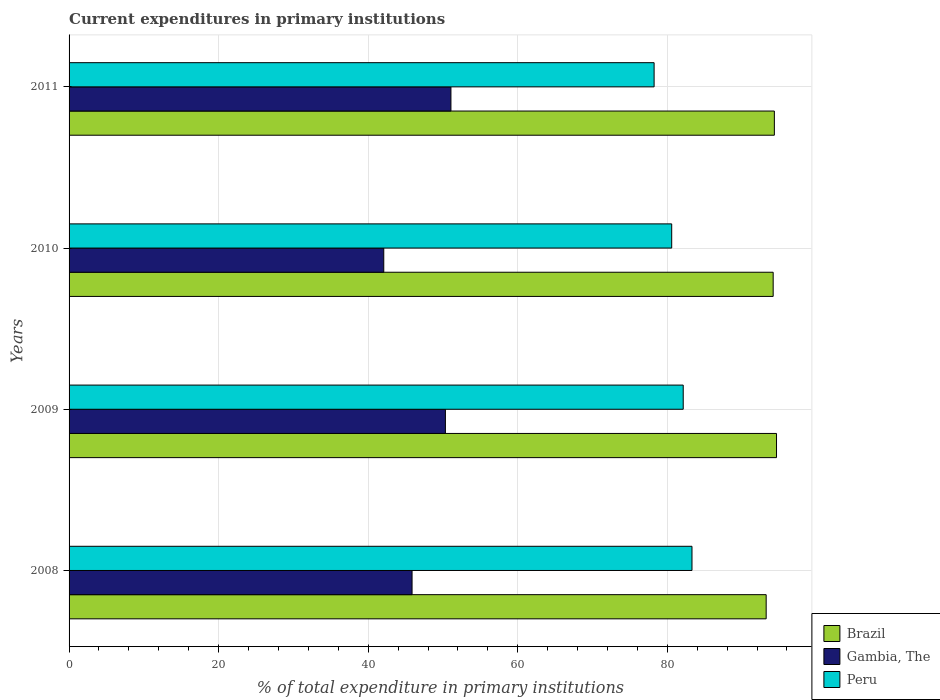How many different coloured bars are there?
Your response must be concise. 3. What is the label of the 1st group of bars from the top?
Make the answer very short. 2011. In how many cases, is the number of bars for a given year not equal to the number of legend labels?
Your response must be concise. 0. What is the current expenditures in primary institutions in Peru in 2008?
Ensure brevity in your answer.  83.3. Across all years, what is the maximum current expenditures in primary institutions in Peru?
Offer a very short reply. 83.3. Across all years, what is the minimum current expenditures in primary institutions in Peru?
Keep it short and to the point. 78.24. In which year was the current expenditures in primary institutions in Gambia, The maximum?
Provide a succinct answer. 2011. In which year was the current expenditures in primary institutions in Brazil minimum?
Keep it short and to the point. 2008. What is the total current expenditures in primary institutions in Brazil in the graph?
Make the answer very short. 376.3. What is the difference between the current expenditures in primary institutions in Brazil in 2008 and that in 2010?
Your answer should be very brief. -0.94. What is the difference between the current expenditures in primary institutions in Gambia, The in 2010 and the current expenditures in primary institutions in Peru in 2009?
Offer a very short reply. -40.05. What is the average current expenditures in primary institutions in Gambia, The per year?
Give a very brief answer. 47.34. In the year 2011, what is the difference between the current expenditures in primary institutions in Peru and current expenditures in primary institutions in Gambia, The?
Your answer should be compact. 27.17. In how many years, is the current expenditures in primary institutions in Peru greater than 40 %?
Your answer should be compact. 4. What is the ratio of the current expenditures in primary institutions in Gambia, The in 2008 to that in 2010?
Offer a very short reply. 1.09. What is the difference between the highest and the second highest current expenditures in primary institutions in Gambia, The?
Give a very brief answer. 0.74. What is the difference between the highest and the lowest current expenditures in primary institutions in Peru?
Offer a terse response. 5.07. Is the sum of the current expenditures in primary institutions in Gambia, The in 2010 and 2011 greater than the maximum current expenditures in primary institutions in Peru across all years?
Your answer should be compact. Yes. What does the 2nd bar from the top in 2008 represents?
Your response must be concise. Gambia, The. How many years are there in the graph?
Make the answer very short. 4. Does the graph contain grids?
Keep it short and to the point. Yes. How are the legend labels stacked?
Provide a succinct answer. Vertical. What is the title of the graph?
Keep it short and to the point. Current expenditures in primary institutions. What is the label or title of the X-axis?
Offer a terse response. % of total expenditure in primary institutions. What is the label or title of the Y-axis?
Offer a very short reply. Years. What is the % of total expenditure in primary institutions of Brazil in 2008?
Your response must be concise. 93.22. What is the % of total expenditure in primary institutions in Gambia, The in 2008?
Make the answer very short. 45.87. What is the % of total expenditure in primary institutions in Peru in 2008?
Give a very brief answer. 83.3. What is the % of total expenditure in primary institutions of Brazil in 2009?
Give a very brief answer. 94.6. What is the % of total expenditure in primary institutions in Gambia, The in 2009?
Offer a very short reply. 50.33. What is the % of total expenditure in primary institutions of Peru in 2009?
Provide a short and direct response. 82.13. What is the % of total expenditure in primary institutions in Brazil in 2010?
Offer a very short reply. 94.16. What is the % of total expenditure in primary institutions of Gambia, The in 2010?
Your answer should be compact. 42.08. What is the % of total expenditure in primary institutions in Peru in 2010?
Offer a very short reply. 80.59. What is the % of total expenditure in primary institutions in Brazil in 2011?
Make the answer very short. 94.32. What is the % of total expenditure in primary institutions in Gambia, The in 2011?
Your answer should be very brief. 51.07. What is the % of total expenditure in primary institutions in Peru in 2011?
Provide a short and direct response. 78.24. Across all years, what is the maximum % of total expenditure in primary institutions of Brazil?
Provide a short and direct response. 94.6. Across all years, what is the maximum % of total expenditure in primary institutions in Gambia, The?
Ensure brevity in your answer.  51.07. Across all years, what is the maximum % of total expenditure in primary institutions in Peru?
Provide a succinct answer. 83.3. Across all years, what is the minimum % of total expenditure in primary institutions of Brazil?
Your answer should be compact. 93.22. Across all years, what is the minimum % of total expenditure in primary institutions in Gambia, The?
Offer a terse response. 42.08. Across all years, what is the minimum % of total expenditure in primary institutions of Peru?
Give a very brief answer. 78.24. What is the total % of total expenditure in primary institutions in Brazil in the graph?
Provide a short and direct response. 376.3. What is the total % of total expenditure in primary institutions of Gambia, The in the graph?
Keep it short and to the point. 189.34. What is the total % of total expenditure in primary institutions of Peru in the graph?
Keep it short and to the point. 324.25. What is the difference between the % of total expenditure in primary institutions of Brazil in 2008 and that in 2009?
Your answer should be very brief. -1.38. What is the difference between the % of total expenditure in primary institutions in Gambia, The in 2008 and that in 2009?
Provide a short and direct response. -4.46. What is the difference between the % of total expenditure in primary institutions in Peru in 2008 and that in 2009?
Offer a terse response. 1.17. What is the difference between the % of total expenditure in primary institutions in Brazil in 2008 and that in 2010?
Provide a succinct answer. -0.94. What is the difference between the % of total expenditure in primary institutions of Gambia, The in 2008 and that in 2010?
Provide a short and direct response. 3.78. What is the difference between the % of total expenditure in primary institutions of Peru in 2008 and that in 2010?
Keep it short and to the point. 2.71. What is the difference between the % of total expenditure in primary institutions of Brazil in 2008 and that in 2011?
Offer a terse response. -1.1. What is the difference between the % of total expenditure in primary institutions of Gambia, The in 2008 and that in 2011?
Make the answer very short. -5.2. What is the difference between the % of total expenditure in primary institutions of Peru in 2008 and that in 2011?
Provide a short and direct response. 5.07. What is the difference between the % of total expenditure in primary institutions of Brazil in 2009 and that in 2010?
Your answer should be compact. 0.45. What is the difference between the % of total expenditure in primary institutions in Gambia, The in 2009 and that in 2010?
Provide a succinct answer. 8.24. What is the difference between the % of total expenditure in primary institutions in Peru in 2009 and that in 2010?
Provide a succinct answer. 1.54. What is the difference between the % of total expenditure in primary institutions of Brazil in 2009 and that in 2011?
Give a very brief answer. 0.29. What is the difference between the % of total expenditure in primary institutions of Gambia, The in 2009 and that in 2011?
Keep it short and to the point. -0.74. What is the difference between the % of total expenditure in primary institutions in Peru in 2009 and that in 2011?
Your answer should be very brief. 3.89. What is the difference between the % of total expenditure in primary institutions of Brazil in 2010 and that in 2011?
Provide a short and direct response. -0.16. What is the difference between the % of total expenditure in primary institutions in Gambia, The in 2010 and that in 2011?
Your answer should be very brief. -8.98. What is the difference between the % of total expenditure in primary institutions of Peru in 2010 and that in 2011?
Offer a very short reply. 2.35. What is the difference between the % of total expenditure in primary institutions in Brazil in 2008 and the % of total expenditure in primary institutions in Gambia, The in 2009?
Ensure brevity in your answer.  42.9. What is the difference between the % of total expenditure in primary institutions of Brazil in 2008 and the % of total expenditure in primary institutions of Peru in 2009?
Keep it short and to the point. 11.09. What is the difference between the % of total expenditure in primary institutions in Gambia, The in 2008 and the % of total expenditure in primary institutions in Peru in 2009?
Give a very brief answer. -36.26. What is the difference between the % of total expenditure in primary institutions in Brazil in 2008 and the % of total expenditure in primary institutions in Gambia, The in 2010?
Your response must be concise. 51.14. What is the difference between the % of total expenditure in primary institutions of Brazil in 2008 and the % of total expenditure in primary institutions of Peru in 2010?
Your answer should be compact. 12.63. What is the difference between the % of total expenditure in primary institutions in Gambia, The in 2008 and the % of total expenditure in primary institutions in Peru in 2010?
Keep it short and to the point. -34.72. What is the difference between the % of total expenditure in primary institutions in Brazil in 2008 and the % of total expenditure in primary institutions in Gambia, The in 2011?
Keep it short and to the point. 42.16. What is the difference between the % of total expenditure in primary institutions in Brazil in 2008 and the % of total expenditure in primary institutions in Peru in 2011?
Make the answer very short. 14.99. What is the difference between the % of total expenditure in primary institutions of Gambia, The in 2008 and the % of total expenditure in primary institutions of Peru in 2011?
Keep it short and to the point. -32.37. What is the difference between the % of total expenditure in primary institutions of Brazil in 2009 and the % of total expenditure in primary institutions of Gambia, The in 2010?
Provide a short and direct response. 52.52. What is the difference between the % of total expenditure in primary institutions of Brazil in 2009 and the % of total expenditure in primary institutions of Peru in 2010?
Keep it short and to the point. 14.02. What is the difference between the % of total expenditure in primary institutions of Gambia, The in 2009 and the % of total expenditure in primary institutions of Peru in 2010?
Your answer should be compact. -30.26. What is the difference between the % of total expenditure in primary institutions in Brazil in 2009 and the % of total expenditure in primary institutions in Gambia, The in 2011?
Your answer should be compact. 43.54. What is the difference between the % of total expenditure in primary institutions in Brazil in 2009 and the % of total expenditure in primary institutions in Peru in 2011?
Ensure brevity in your answer.  16.37. What is the difference between the % of total expenditure in primary institutions in Gambia, The in 2009 and the % of total expenditure in primary institutions in Peru in 2011?
Keep it short and to the point. -27.91. What is the difference between the % of total expenditure in primary institutions of Brazil in 2010 and the % of total expenditure in primary institutions of Gambia, The in 2011?
Make the answer very short. 43.09. What is the difference between the % of total expenditure in primary institutions of Brazil in 2010 and the % of total expenditure in primary institutions of Peru in 2011?
Offer a very short reply. 15.92. What is the difference between the % of total expenditure in primary institutions in Gambia, The in 2010 and the % of total expenditure in primary institutions in Peru in 2011?
Your answer should be compact. -36.15. What is the average % of total expenditure in primary institutions in Brazil per year?
Keep it short and to the point. 94.08. What is the average % of total expenditure in primary institutions of Gambia, The per year?
Offer a terse response. 47.34. What is the average % of total expenditure in primary institutions in Peru per year?
Make the answer very short. 81.06. In the year 2008, what is the difference between the % of total expenditure in primary institutions of Brazil and % of total expenditure in primary institutions of Gambia, The?
Offer a terse response. 47.35. In the year 2008, what is the difference between the % of total expenditure in primary institutions of Brazil and % of total expenditure in primary institutions of Peru?
Your response must be concise. 9.92. In the year 2008, what is the difference between the % of total expenditure in primary institutions of Gambia, The and % of total expenditure in primary institutions of Peru?
Your answer should be compact. -37.43. In the year 2009, what is the difference between the % of total expenditure in primary institutions of Brazil and % of total expenditure in primary institutions of Gambia, The?
Your response must be concise. 44.28. In the year 2009, what is the difference between the % of total expenditure in primary institutions of Brazil and % of total expenditure in primary institutions of Peru?
Your response must be concise. 12.48. In the year 2009, what is the difference between the % of total expenditure in primary institutions of Gambia, The and % of total expenditure in primary institutions of Peru?
Offer a terse response. -31.8. In the year 2010, what is the difference between the % of total expenditure in primary institutions of Brazil and % of total expenditure in primary institutions of Gambia, The?
Make the answer very short. 52.07. In the year 2010, what is the difference between the % of total expenditure in primary institutions in Brazil and % of total expenditure in primary institutions in Peru?
Your response must be concise. 13.57. In the year 2010, what is the difference between the % of total expenditure in primary institutions of Gambia, The and % of total expenditure in primary institutions of Peru?
Offer a very short reply. -38.51. In the year 2011, what is the difference between the % of total expenditure in primary institutions of Brazil and % of total expenditure in primary institutions of Gambia, The?
Provide a short and direct response. 43.25. In the year 2011, what is the difference between the % of total expenditure in primary institutions in Brazil and % of total expenditure in primary institutions in Peru?
Make the answer very short. 16.08. In the year 2011, what is the difference between the % of total expenditure in primary institutions of Gambia, The and % of total expenditure in primary institutions of Peru?
Provide a short and direct response. -27.17. What is the ratio of the % of total expenditure in primary institutions in Brazil in 2008 to that in 2009?
Keep it short and to the point. 0.99. What is the ratio of the % of total expenditure in primary institutions in Gambia, The in 2008 to that in 2009?
Keep it short and to the point. 0.91. What is the ratio of the % of total expenditure in primary institutions of Peru in 2008 to that in 2009?
Your answer should be very brief. 1.01. What is the ratio of the % of total expenditure in primary institutions in Gambia, The in 2008 to that in 2010?
Your answer should be very brief. 1.09. What is the ratio of the % of total expenditure in primary institutions of Peru in 2008 to that in 2010?
Your answer should be compact. 1.03. What is the ratio of the % of total expenditure in primary institutions in Brazil in 2008 to that in 2011?
Give a very brief answer. 0.99. What is the ratio of the % of total expenditure in primary institutions of Gambia, The in 2008 to that in 2011?
Your answer should be very brief. 0.9. What is the ratio of the % of total expenditure in primary institutions of Peru in 2008 to that in 2011?
Your response must be concise. 1.06. What is the ratio of the % of total expenditure in primary institutions of Gambia, The in 2009 to that in 2010?
Keep it short and to the point. 1.2. What is the ratio of the % of total expenditure in primary institutions of Peru in 2009 to that in 2010?
Provide a short and direct response. 1.02. What is the ratio of the % of total expenditure in primary institutions of Gambia, The in 2009 to that in 2011?
Give a very brief answer. 0.99. What is the ratio of the % of total expenditure in primary institutions in Peru in 2009 to that in 2011?
Give a very brief answer. 1.05. What is the ratio of the % of total expenditure in primary institutions of Brazil in 2010 to that in 2011?
Give a very brief answer. 1. What is the ratio of the % of total expenditure in primary institutions in Gambia, The in 2010 to that in 2011?
Provide a succinct answer. 0.82. What is the ratio of the % of total expenditure in primary institutions of Peru in 2010 to that in 2011?
Make the answer very short. 1.03. What is the difference between the highest and the second highest % of total expenditure in primary institutions in Brazil?
Make the answer very short. 0.29. What is the difference between the highest and the second highest % of total expenditure in primary institutions in Gambia, The?
Provide a succinct answer. 0.74. What is the difference between the highest and the second highest % of total expenditure in primary institutions in Peru?
Offer a terse response. 1.17. What is the difference between the highest and the lowest % of total expenditure in primary institutions in Brazil?
Give a very brief answer. 1.38. What is the difference between the highest and the lowest % of total expenditure in primary institutions in Gambia, The?
Give a very brief answer. 8.98. What is the difference between the highest and the lowest % of total expenditure in primary institutions of Peru?
Give a very brief answer. 5.07. 